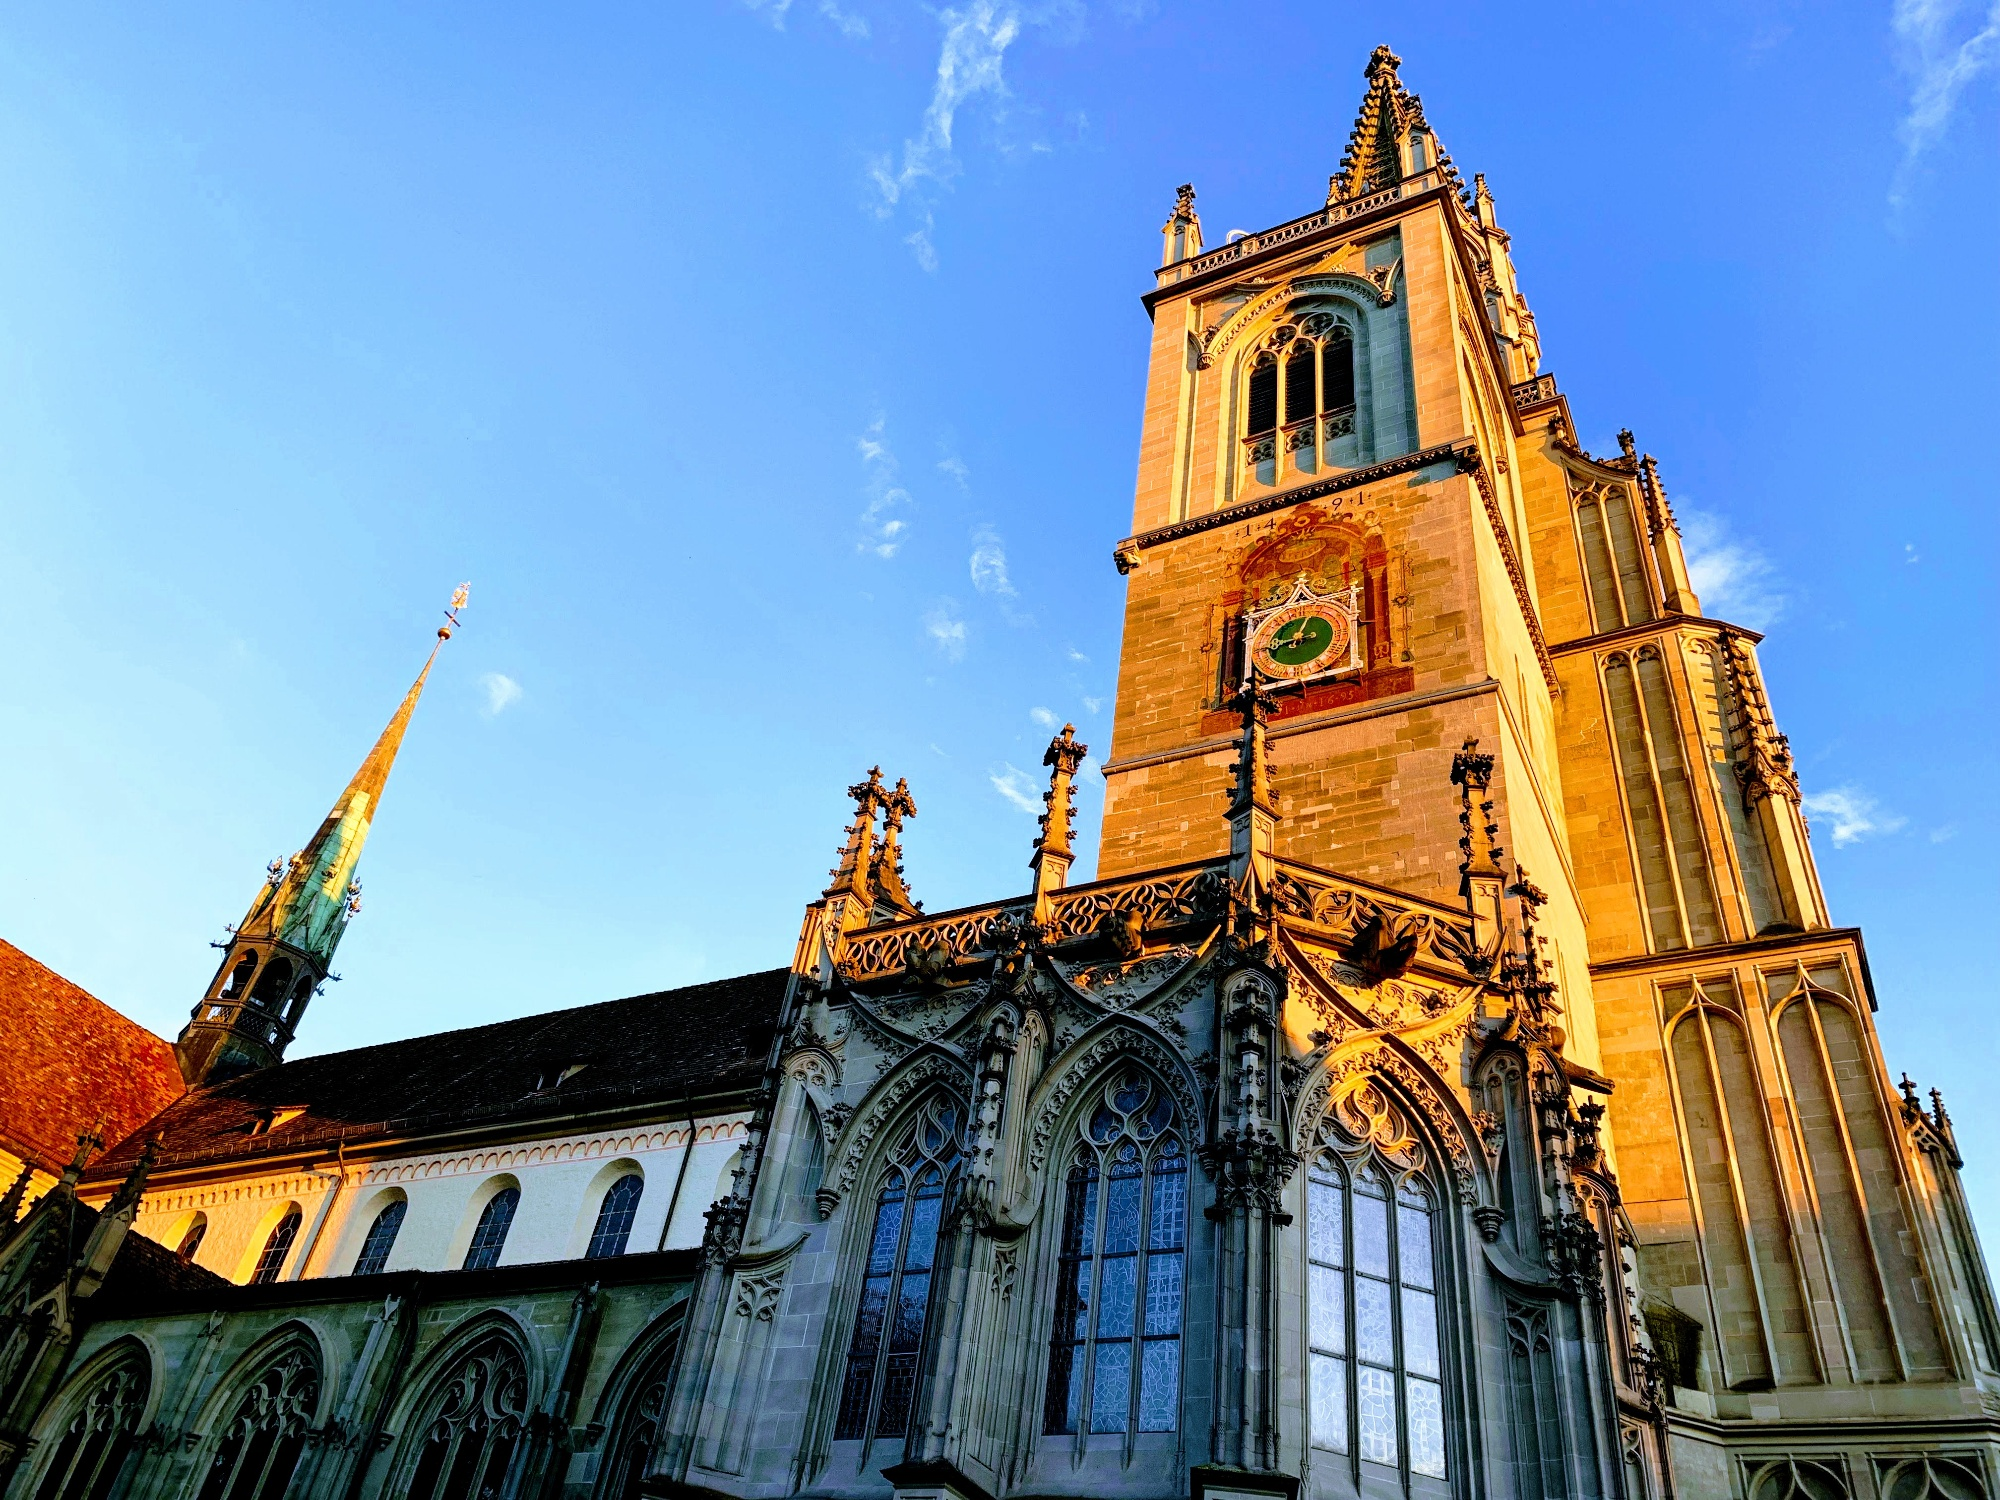What historical events are associated with this landmark? Konstanz Minster is steeped in history, most notably for its association with the Council of Constance held between 1414 and 1418. This was a pivotal moment in ecclesiastical history, where major decisions were made, including the election of Pope Martin V, effectively ending the Western Schism. The cathedral itself dates back to the 7th century and has witnessed numerous historical events through the ages. Its Gothic architecture and enduring presence make it a symbol of both religious and cultural heritage in the region. 